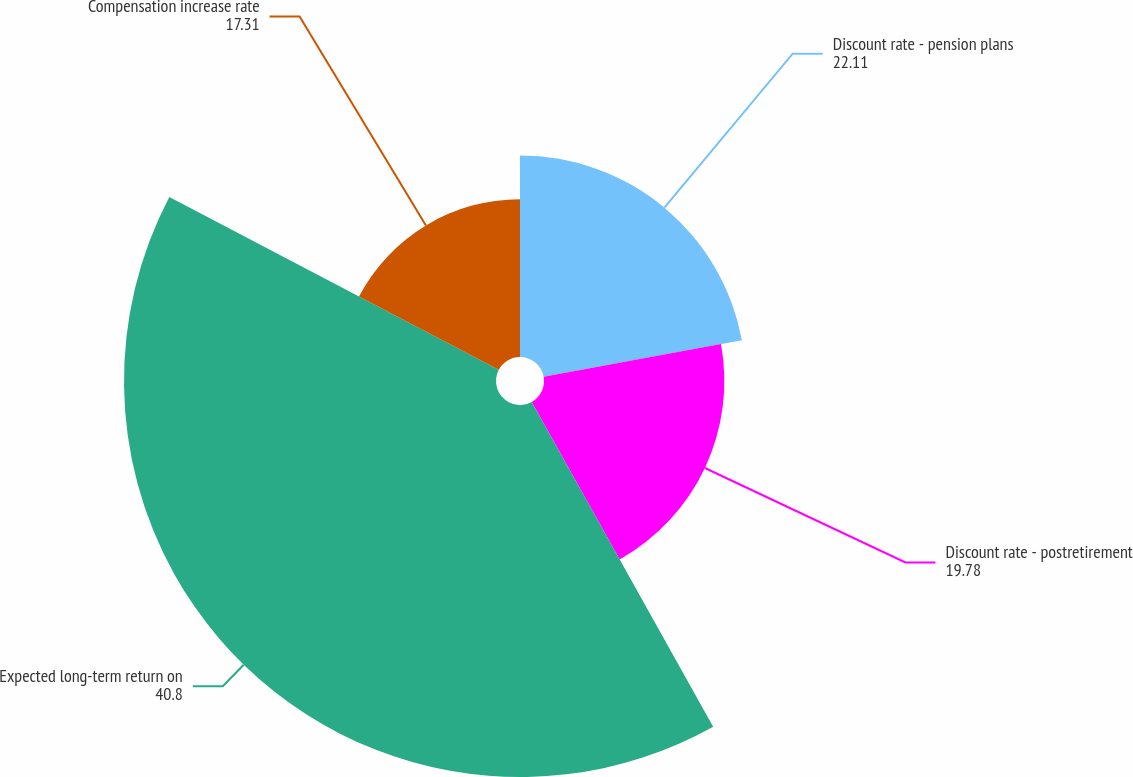Convert chart to OTSL. <chart><loc_0><loc_0><loc_500><loc_500><pie_chart><fcel>Discount rate - pension plans<fcel>Discount rate - postretirement<fcel>Expected long-term return on<fcel>Compensation increase rate<nl><fcel>22.11%<fcel>19.78%<fcel>40.8%<fcel>17.31%<nl></chart> 